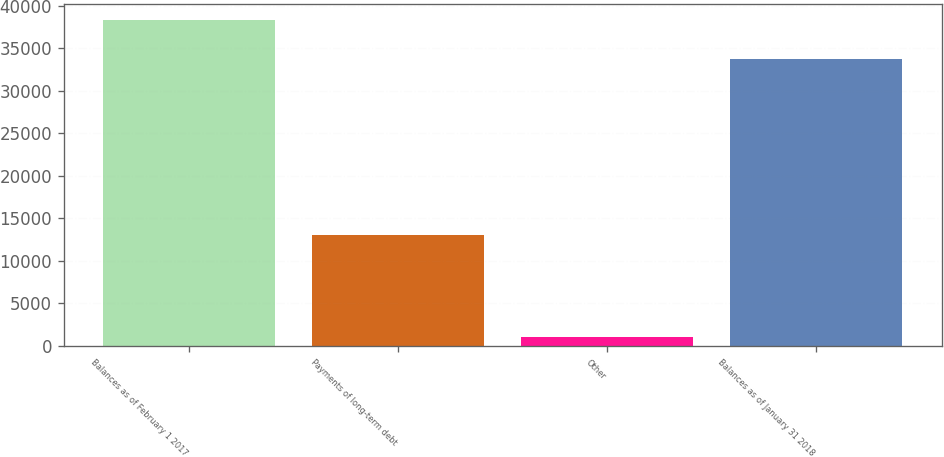Convert chart. <chart><loc_0><loc_0><loc_500><loc_500><bar_chart><fcel>Balances as of February 1 2017<fcel>Payments of long-term debt<fcel>Other<fcel>Balances as of January 31 2018<nl><fcel>38271<fcel>13061<fcel>1097<fcel>33783<nl></chart> 